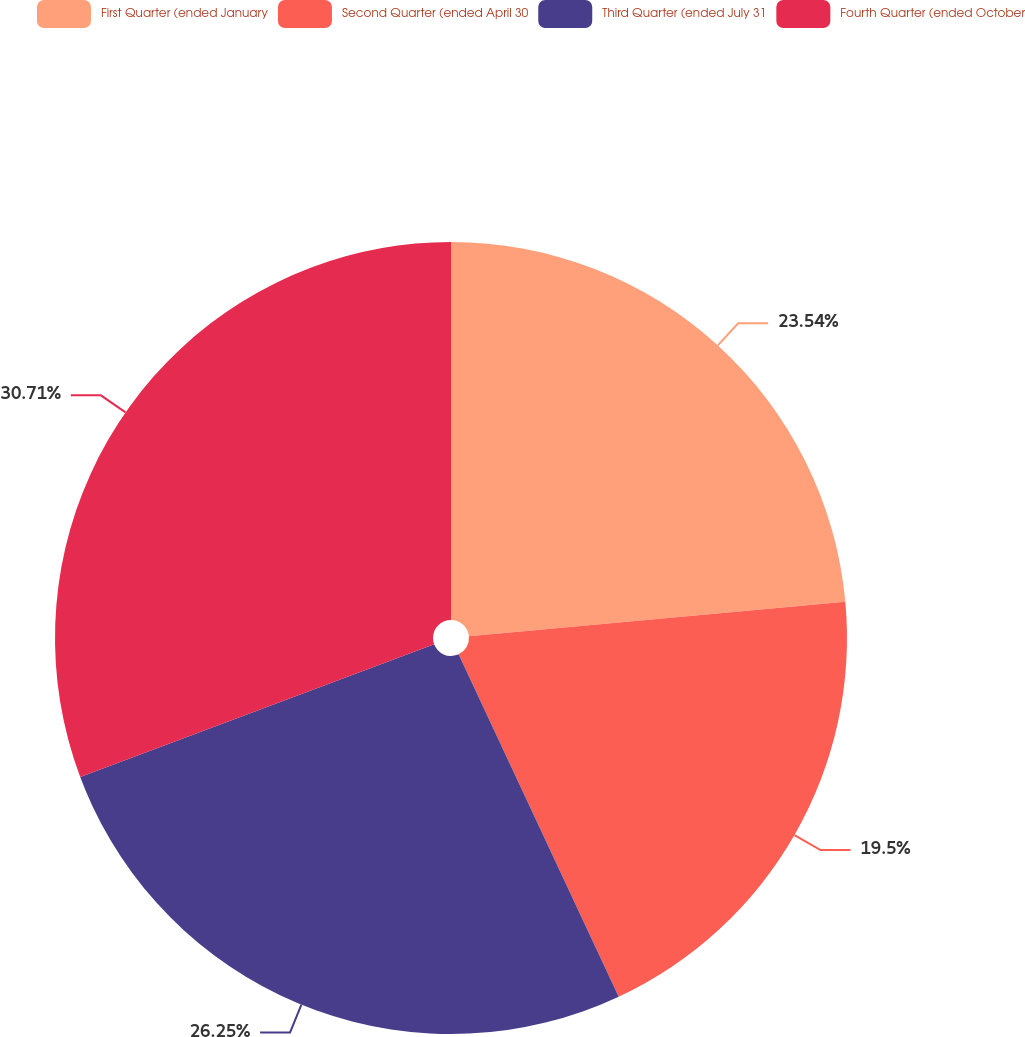Convert chart to OTSL. <chart><loc_0><loc_0><loc_500><loc_500><pie_chart><fcel>First Quarter (ended January<fcel>Second Quarter (ended April 30<fcel>Third Quarter (ended July 31<fcel>Fourth Quarter (ended October<nl><fcel>23.54%<fcel>19.5%<fcel>26.25%<fcel>30.71%<nl></chart> 